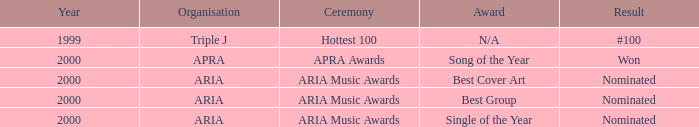What were the results before the year 2000? #100. 